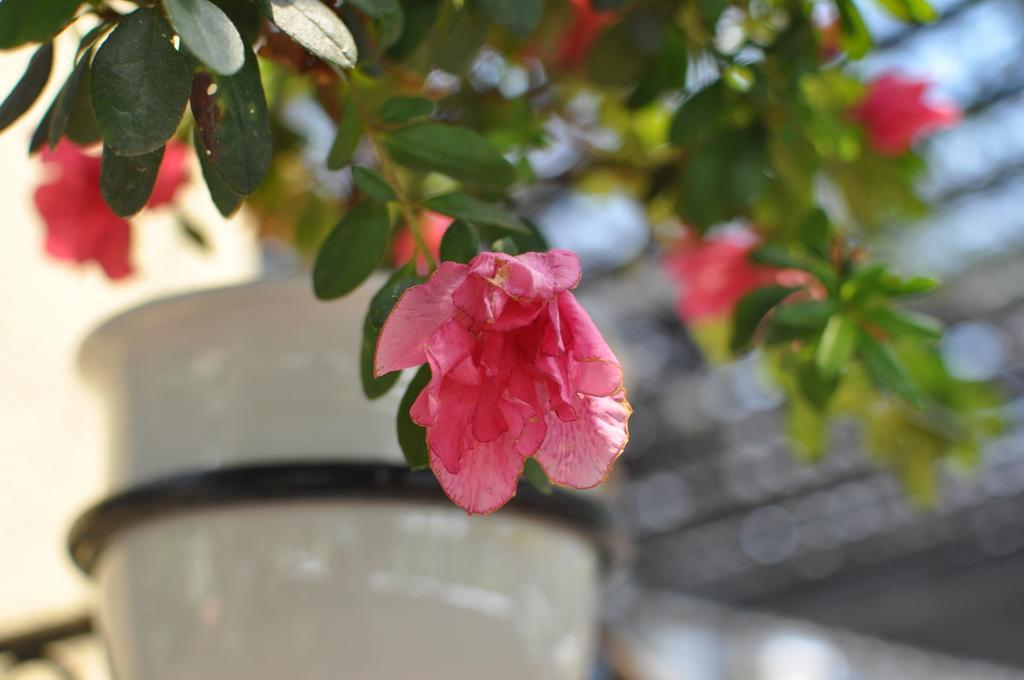What type of plant can be seen in the image? There is a tree in the image. What colors are present on the tree? The tree has pink color flowers and green color leaves. How would you describe the background of the image? The background of the image is blurred. What type of neck accessory is hanging from the tree in the image? There is no neck accessory present in the image; it features a tree with pink flowers and green leaves. Can you see a stamp on any of the leaves in the image? There is no stamp present on the leaves in the image; the tree has only flowers and leaves. 